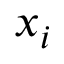Convert formula to latex. <formula><loc_0><loc_0><loc_500><loc_500>x _ { i }</formula> 